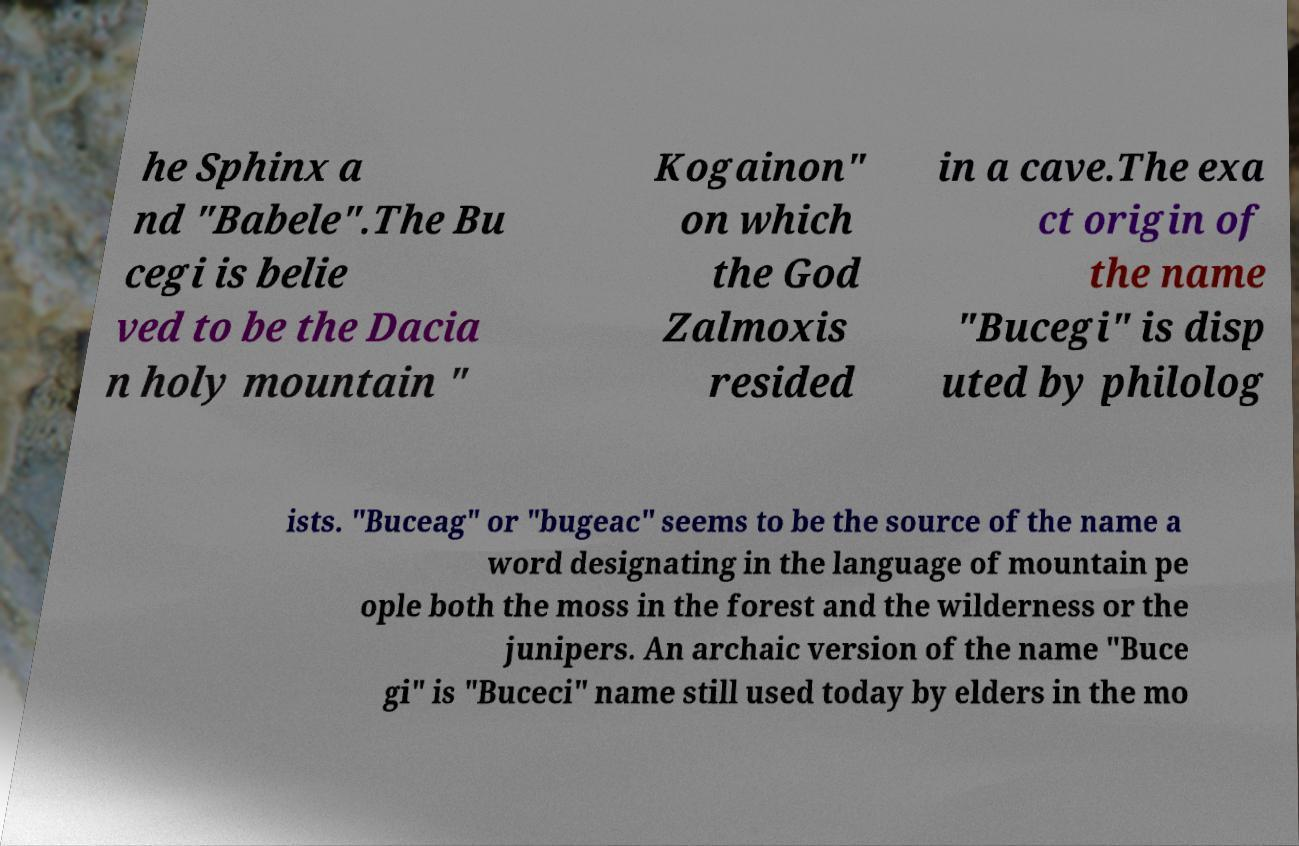Please identify and transcribe the text found in this image. he Sphinx a nd "Babele".The Bu cegi is belie ved to be the Dacia n holy mountain " Kogainon" on which the God Zalmoxis resided in a cave.The exa ct origin of the name "Bucegi" is disp uted by philolog ists. "Buceag" or "bugeac" seems to be the source of the name a word designating in the language of mountain pe ople both the moss in the forest and the wilderness or the junipers. An archaic version of the name "Buce gi" is "Buceci" name still used today by elders in the mo 